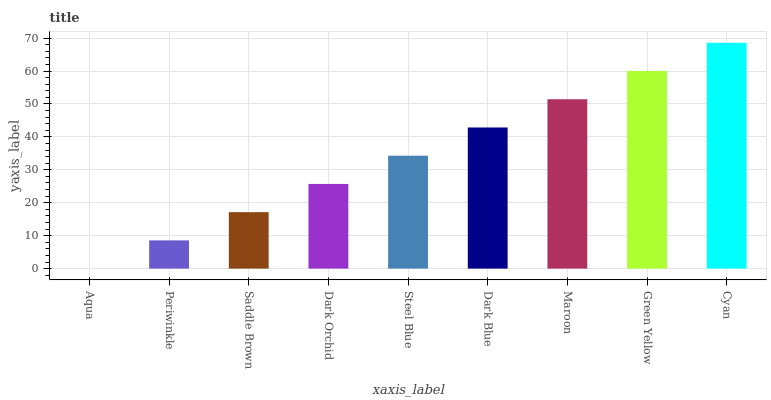Is Aqua the minimum?
Answer yes or no. Yes. Is Cyan the maximum?
Answer yes or no. Yes. Is Periwinkle the minimum?
Answer yes or no. No. Is Periwinkle the maximum?
Answer yes or no. No. Is Periwinkle greater than Aqua?
Answer yes or no. Yes. Is Aqua less than Periwinkle?
Answer yes or no. Yes. Is Aqua greater than Periwinkle?
Answer yes or no. No. Is Periwinkle less than Aqua?
Answer yes or no. No. Is Steel Blue the high median?
Answer yes or no. Yes. Is Steel Blue the low median?
Answer yes or no. Yes. Is Saddle Brown the high median?
Answer yes or no. No. Is Periwinkle the low median?
Answer yes or no. No. 